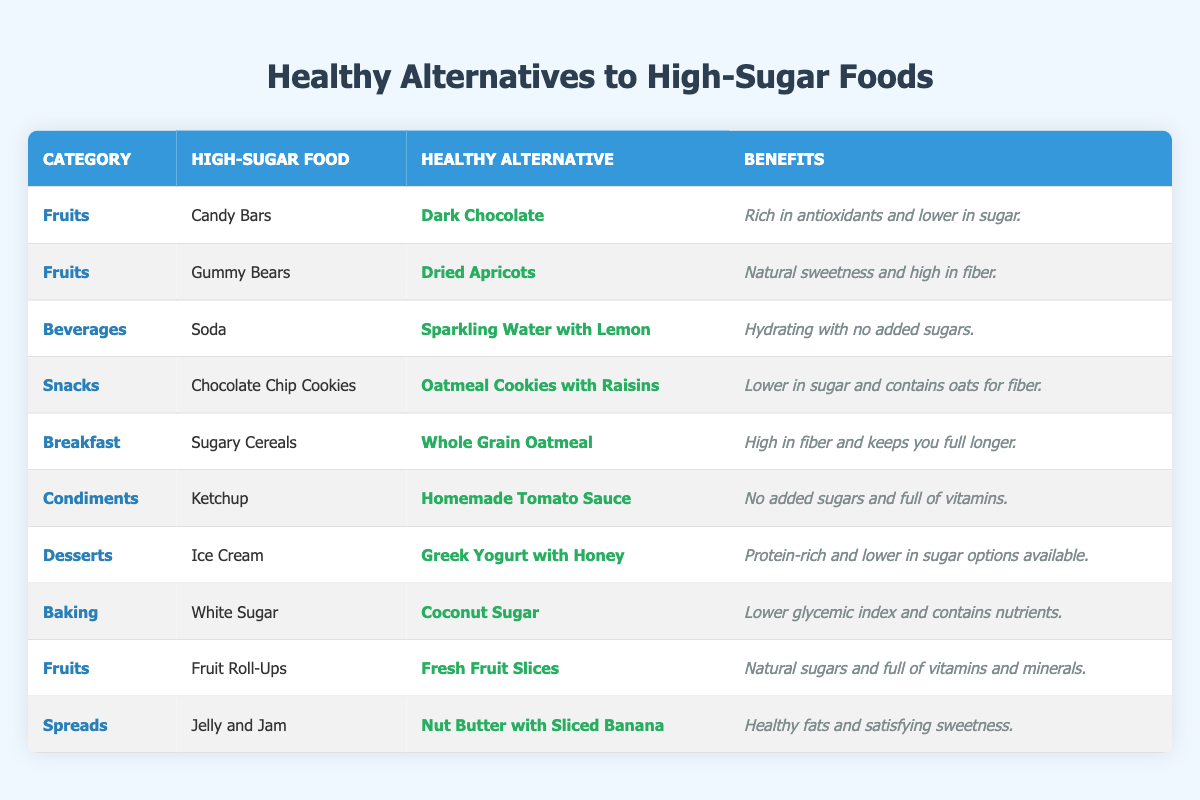What is the healthy alternative to Ice Cream? According to the table, the row for Ice Cream lists **Greek Yogurt with Honey** as its healthy alternative.
Answer: Greek Yogurt with Honey Which high-sugar food has the healthy alternative of **Homemade Tomato Sauce**? By scanning the table, we see that the healthy alternative **Homemade Tomato Sauce** corresponds to Ketchup.
Answer: Ketchup Which category does **Nut Butter with Sliced Banana** belong to? In the table, **Nut Butter with Sliced Banana** is listed under the category of Spreads.
Answer: Spreads Is **Dark Chocolate** lower in sugar than Candy Bars? The benefits of **Dark Chocolate** indicate it is lower in sugar than Candy Bars.
Answer: Yes Which healthy alternative is recommended for sugary cereals? The table specifies that **Whole Grain Oatmeal** is the healthy alternative for sugary cereals.
Answer: Whole Grain Oatmeal If you were to replace all the high-sugar foods with their healthy alternatives in the table, how many alternatives would you have? There are 10 unique entries in the table, each with a healthy alternative. Thus, if all are replaced, there would be 10 alternatives.
Answer: 10 What benefits does **Dried Apricots** provide compared to Gummy Bears? The benefits listed for **Dried Apricots** are "Natural sweetness and high in fiber," indicating it provides beneficial nutrients compared to high-sugar Gummy Bears.
Answer: Natural sweetness and high in fiber What is a common benefit shared by alternatives to both Ice Cream and Candy Bars? Both alternatives, **Greek Yogurt with Honey** and **Dark Chocolate**, are noted for being lower in sugar than their high-sugar counterparts.
Answer: Lower in sugar How many entries are in the "Fruits" category? There are three entries categorized under "Fruits": Candy Bars, Gummy Bears, and Fruit Roll-Ups, summing to three entries.
Answer: 3 What are the benefits of **Coconut Sugar**? The table states that **Coconut Sugar** is characterized by having a lower glycemic index and containing nutrients.
Answer: Lower glycemic index and contains nutrients 